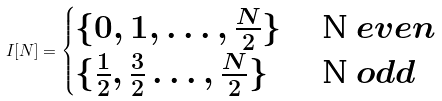Convert formula to latex. <formula><loc_0><loc_0><loc_500><loc_500>I [ N ] = \begin{cases} \{ 0 , 1 , \dots , \frac { N } { 2 } \} & $ N $ e v e n \\ \{ \frac { 1 } { 2 } , \frac { 3 } { 2 } \dots , \frac { N } { 2 } \} & $ N $ o d d \end{cases}</formula> 